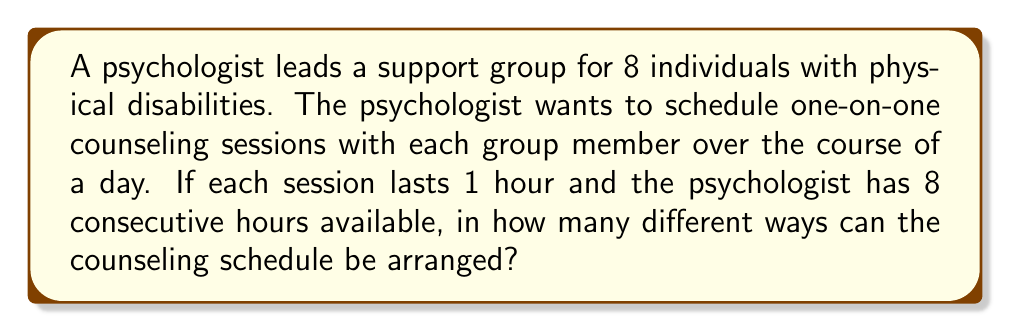Can you answer this question? To solve this problem, we need to recognize that this is a permutation problem. We are arranging 8 distinct individuals into 8 distinct time slots.

The key points to consider are:
1. The order matters (a different order of individuals results in a different schedule).
2. All 8 individuals must be included in the schedule.
3. Each individual is scheduled exactly once.

This scenario fits the definition of a permutation of 8 objects. The formula for permutations is:

$$P(n) = n!$$

Where $n$ is the number of objects to be arranged.

In this case, $n = 8$ (as there are 8 individuals to be scheduled).

Therefore, the number of possible schedules is:

$$P(8) = 8!$$

Calculating this out:

$$8! = 8 \times 7 \times 6 \times 5 \times 4 \times 3 \times 2 \times 1 = 40,320$$

Thus, there are 40,320 different ways to arrange the counseling schedule.
Answer: $40,320$ 